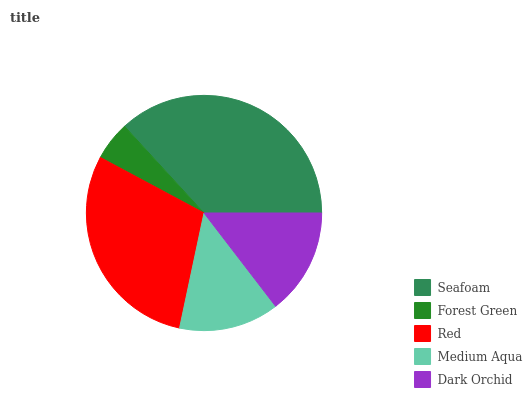Is Forest Green the minimum?
Answer yes or no. Yes. Is Seafoam the maximum?
Answer yes or no. Yes. Is Red the minimum?
Answer yes or no. No. Is Red the maximum?
Answer yes or no. No. Is Red greater than Forest Green?
Answer yes or no. Yes. Is Forest Green less than Red?
Answer yes or no. Yes. Is Forest Green greater than Red?
Answer yes or no. No. Is Red less than Forest Green?
Answer yes or no. No. Is Dark Orchid the high median?
Answer yes or no. Yes. Is Dark Orchid the low median?
Answer yes or no. Yes. Is Forest Green the high median?
Answer yes or no. No. Is Medium Aqua the low median?
Answer yes or no. No. 